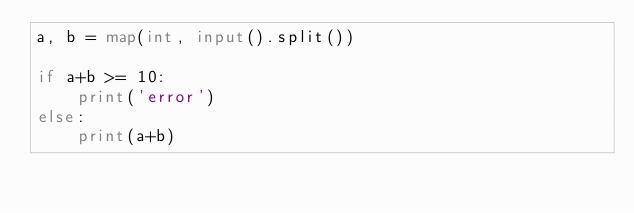Convert code to text. <code><loc_0><loc_0><loc_500><loc_500><_Python_>a, b = map(int, input().split())

if a+b >= 10:
    print('error')
else:
    print(a+b)</code> 